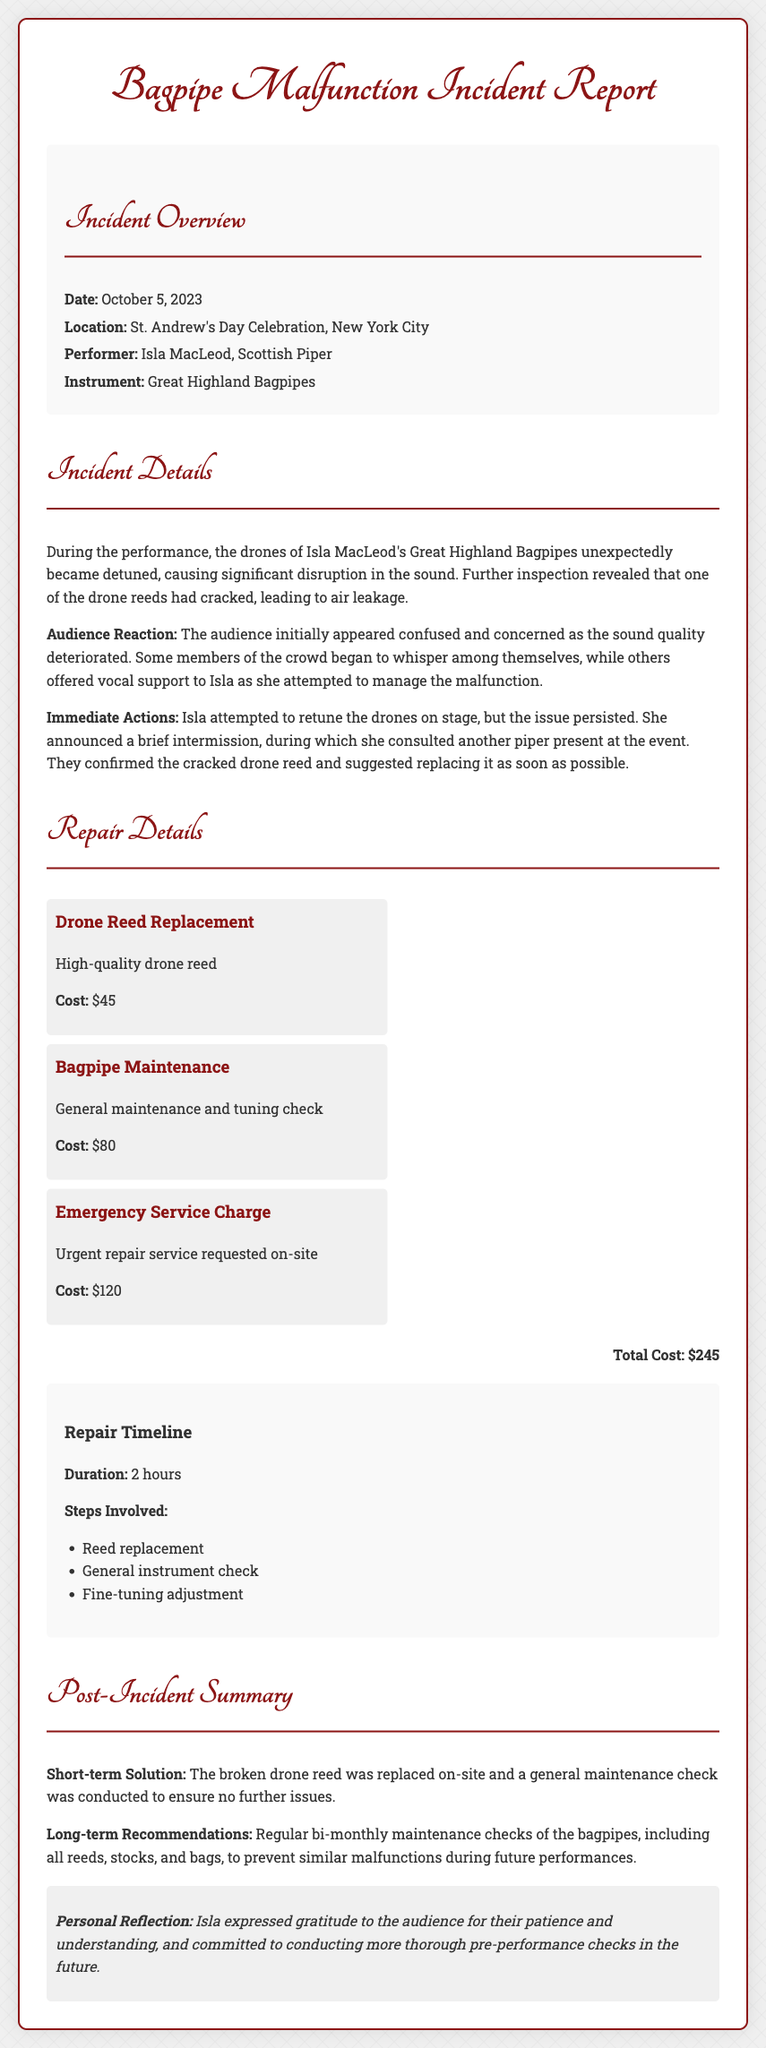What was the date of the incident? The date of the incident is specifically mentioned in the document as October 5, 2023.
Answer: October 5, 2023 Who was the performer during the incident? The document clearly states that the performer was Isla MacLeod, a Scottish Piper.
Answer: Isla MacLeod What caused the disruption in sound? The document explains that the drones became detuned due to a cracked drone reed, leading to air leakage.
Answer: Cracked drone reed What was the total cost for repairs? The total cost of repairs is stated clearly in the document as $245.
Answer: $245 How long did the repair take? The document mentions that the duration of the repair was 2 hours.
Answer: 2 hours What was the emergency service charge? The document lists the emergency service charge as part of the repair costs, which is noted to be $120.
Answer: $120 What short-term solution was implemented? The document states that the broken drone reed was replaced on-site as the short-term solution.
Answer: Replaced on-site What is one long-term recommendation given? The document suggests conducting regular bi-monthly maintenance checks to prevent future issues.
Answer: Regular bi-monthly maintenance checks What was the audience's initial reaction? The document describes the audience as confused and concerned during the sound quality deterioration.
Answer: Confused and concerned 